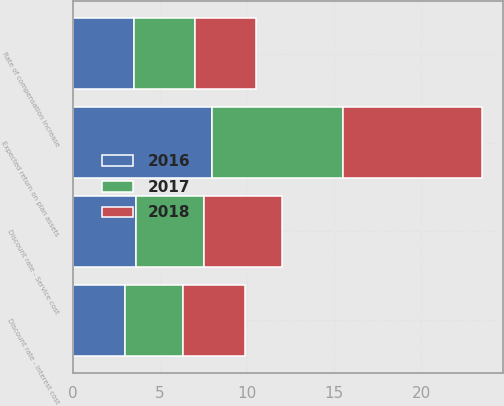Convert chart to OTSL. <chart><loc_0><loc_0><loc_500><loc_500><stacked_bar_chart><ecel><fcel>Discount rate - Service cost<fcel>Discount rate - Interest cost<fcel>Expected return on plan assets<fcel>Rate of compensation increase<nl><fcel>2017<fcel>3.9<fcel>3.3<fcel>7.5<fcel>3.5<nl><fcel>2016<fcel>3.6<fcel>3<fcel>8<fcel>3.5<nl><fcel>2018<fcel>4.5<fcel>3.6<fcel>8<fcel>3.5<nl></chart> 